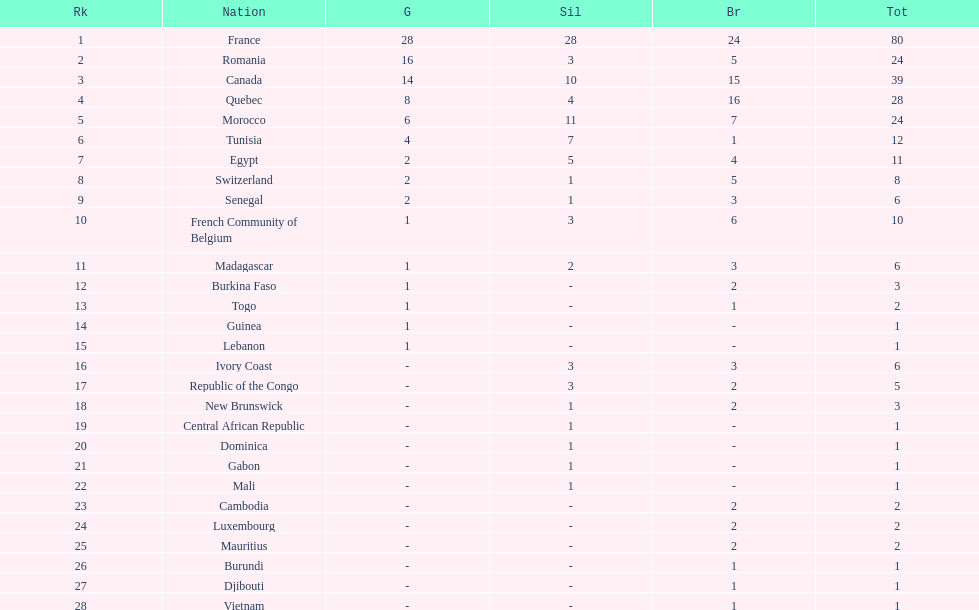How many bronze medals does togo have? 1. 